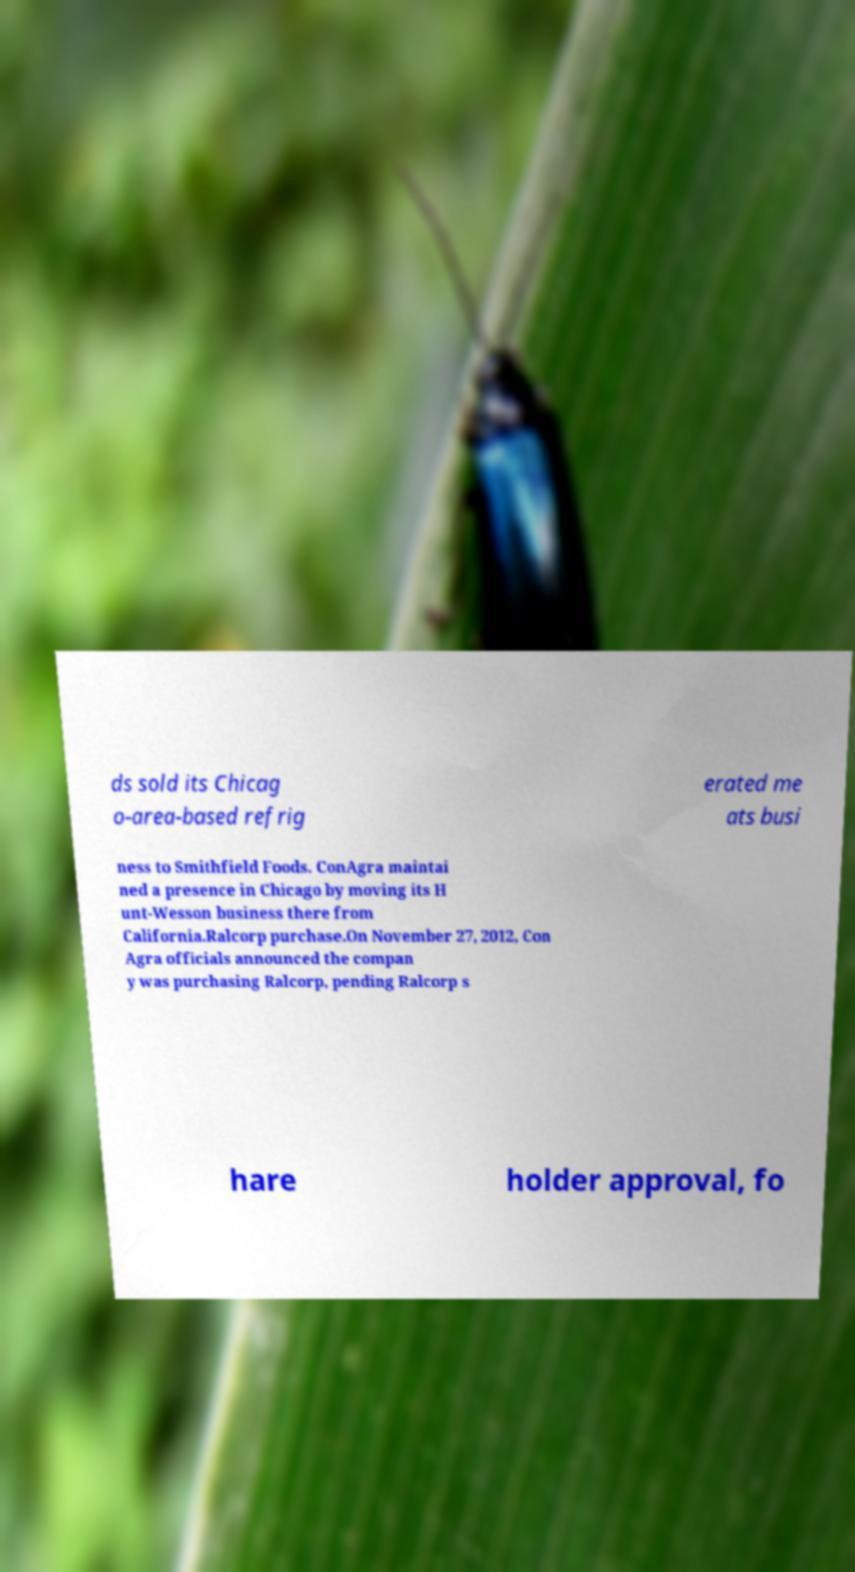Could you assist in decoding the text presented in this image and type it out clearly? ds sold its Chicag o-area-based refrig erated me ats busi ness to Smithfield Foods. ConAgra maintai ned a presence in Chicago by moving its H unt-Wesson business there from California.Ralcorp purchase.On November 27, 2012, Con Agra officials announced the compan y was purchasing Ralcorp, pending Ralcorp s hare holder approval, fo 